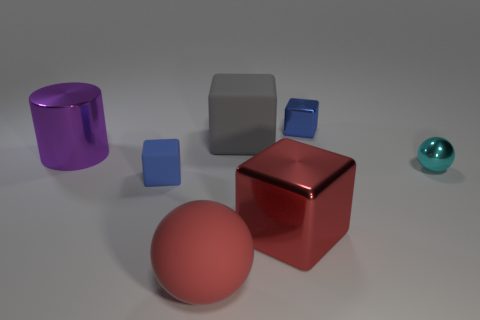What textures do the objects in the image have? The objects in the image display a variety of textures. The red and gray cubes appear to have a smooth matte finish. The purple cylinder seems to have a reflective, slightly brushed surface, while the blue cube presents a light matte texture. The sphere on the right also has a reflective, shiny surface. 